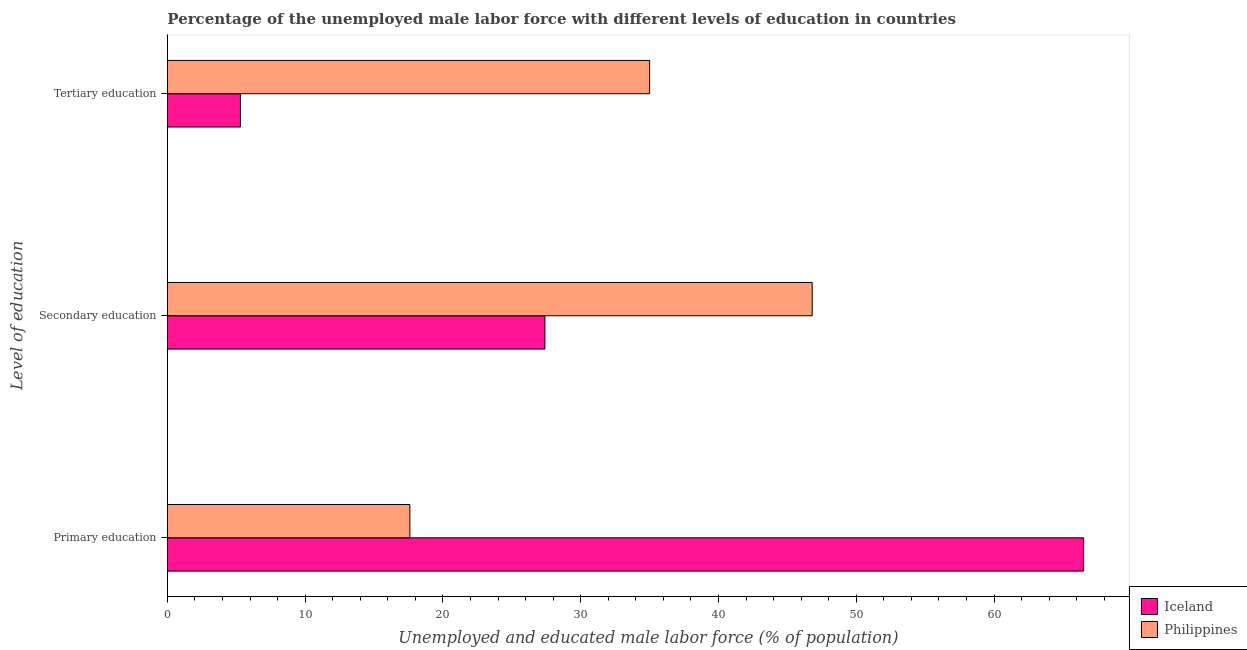How many different coloured bars are there?
Make the answer very short. 2. How many groups of bars are there?
Keep it short and to the point. 3. Are the number of bars per tick equal to the number of legend labels?
Provide a succinct answer. Yes. How many bars are there on the 3rd tick from the bottom?
Your answer should be compact. 2. What is the percentage of male labor force who received secondary education in Iceland?
Your response must be concise. 27.4. Across all countries, what is the maximum percentage of male labor force who received primary education?
Ensure brevity in your answer.  66.5. Across all countries, what is the minimum percentage of male labor force who received tertiary education?
Your answer should be compact. 5.3. What is the total percentage of male labor force who received primary education in the graph?
Your answer should be compact. 84.1. What is the difference between the percentage of male labor force who received tertiary education in Iceland and that in Philippines?
Your answer should be very brief. -29.7. What is the difference between the percentage of male labor force who received primary education in Philippines and the percentage of male labor force who received tertiary education in Iceland?
Your answer should be very brief. 12.3. What is the average percentage of male labor force who received secondary education per country?
Provide a short and direct response. 37.1. What is the difference between the percentage of male labor force who received tertiary education and percentage of male labor force who received secondary education in Philippines?
Your answer should be very brief. -11.8. What is the ratio of the percentage of male labor force who received secondary education in Iceland to that in Philippines?
Provide a short and direct response. 0.59. Is the percentage of male labor force who received secondary education in Philippines less than that in Iceland?
Offer a very short reply. No. Is the difference between the percentage of male labor force who received primary education in Iceland and Philippines greater than the difference between the percentage of male labor force who received tertiary education in Iceland and Philippines?
Offer a terse response. Yes. What is the difference between the highest and the second highest percentage of male labor force who received tertiary education?
Offer a terse response. 29.7. What is the difference between the highest and the lowest percentage of male labor force who received primary education?
Give a very brief answer. 48.9. What does the 2nd bar from the top in Primary education represents?
Your answer should be compact. Iceland. What does the 2nd bar from the bottom in Primary education represents?
Ensure brevity in your answer.  Philippines. Is it the case that in every country, the sum of the percentage of male labor force who received primary education and percentage of male labor force who received secondary education is greater than the percentage of male labor force who received tertiary education?
Your answer should be very brief. Yes. How many bars are there?
Ensure brevity in your answer.  6. Are all the bars in the graph horizontal?
Give a very brief answer. Yes. How many countries are there in the graph?
Provide a short and direct response. 2. What is the difference between two consecutive major ticks on the X-axis?
Provide a succinct answer. 10. Are the values on the major ticks of X-axis written in scientific E-notation?
Provide a succinct answer. No. Does the graph contain grids?
Your answer should be very brief. No. How many legend labels are there?
Ensure brevity in your answer.  2. What is the title of the graph?
Your response must be concise. Percentage of the unemployed male labor force with different levels of education in countries. What is the label or title of the X-axis?
Your response must be concise. Unemployed and educated male labor force (% of population). What is the label or title of the Y-axis?
Your answer should be compact. Level of education. What is the Unemployed and educated male labor force (% of population) of Iceland in Primary education?
Provide a short and direct response. 66.5. What is the Unemployed and educated male labor force (% of population) of Philippines in Primary education?
Keep it short and to the point. 17.6. What is the Unemployed and educated male labor force (% of population) of Iceland in Secondary education?
Offer a terse response. 27.4. What is the Unemployed and educated male labor force (% of population) in Philippines in Secondary education?
Make the answer very short. 46.8. What is the Unemployed and educated male labor force (% of population) of Iceland in Tertiary education?
Your response must be concise. 5.3. What is the Unemployed and educated male labor force (% of population) in Philippines in Tertiary education?
Offer a very short reply. 35. Across all Level of education, what is the maximum Unemployed and educated male labor force (% of population) in Iceland?
Provide a short and direct response. 66.5. Across all Level of education, what is the maximum Unemployed and educated male labor force (% of population) of Philippines?
Your answer should be very brief. 46.8. Across all Level of education, what is the minimum Unemployed and educated male labor force (% of population) of Iceland?
Provide a succinct answer. 5.3. Across all Level of education, what is the minimum Unemployed and educated male labor force (% of population) of Philippines?
Offer a terse response. 17.6. What is the total Unemployed and educated male labor force (% of population) in Iceland in the graph?
Keep it short and to the point. 99.2. What is the total Unemployed and educated male labor force (% of population) of Philippines in the graph?
Ensure brevity in your answer.  99.4. What is the difference between the Unemployed and educated male labor force (% of population) in Iceland in Primary education and that in Secondary education?
Provide a succinct answer. 39.1. What is the difference between the Unemployed and educated male labor force (% of population) of Philippines in Primary education and that in Secondary education?
Your answer should be very brief. -29.2. What is the difference between the Unemployed and educated male labor force (% of population) of Iceland in Primary education and that in Tertiary education?
Provide a short and direct response. 61.2. What is the difference between the Unemployed and educated male labor force (% of population) in Philippines in Primary education and that in Tertiary education?
Give a very brief answer. -17.4. What is the difference between the Unemployed and educated male labor force (% of population) in Iceland in Secondary education and that in Tertiary education?
Provide a succinct answer. 22.1. What is the difference between the Unemployed and educated male labor force (% of population) in Philippines in Secondary education and that in Tertiary education?
Make the answer very short. 11.8. What is the difference between the Unemployed and educated male labor force (% of population) of Iceland in Primary education and the Unemployed and educated male labor force (% of population) of Philippines in Tertiary education?
Make the answer very short. 31.5. What is the average Unemployed and educated male labor force (% of population) of Iceland per Level of education?
Keep it short and to the point. 33.07. What is the average Unemployed and educated male labor force (% of population) of Philippines per Level of education?
Your answer should be compact. 33.13. What is the difference between the Unemployed and educated male labor force (% of population) of Iceland and Unemployed and educated male labor force (% of population) of Philippines in Primary education?
Your answer should be very brief. 48.9. What is the difference between the Unemployed and educated male labor force (% of population) in Iceland and Unemployed and educated male labor force (% of population) in Philippines in Secondary education?
Provide a short and direct response. -19.4. What is the difference between the Unemployed and educated male labor force (% of population) in Iceland and Unemployed and educated male labor force (% of population) in Philippines in Tertiary education?
Provide a short and direct response. -29.7. What is the ratio of the Unemployed and educated male labor force (% of population) in Iceland in Primary education to that in Secondary education?
Your answer should be compact. 2.43. What is the ratio of the Unemployed and educated male labor force (% of population) in Philippines in Primary education to that in Secondary education?
Your answer should be compact. 0.38. What is the ratio of the Unemployed and educated male labor force (% of population) in Iceland in Primary education to that in Tertiary education?
Your answer should be compact. 12.55. What is the ratio of the Unemployed and educated male labor force (% of population) in Philippines in Primary education to that in Tertiary education?
Your response must be concise. 0.5. What is the ratio of the Unemployed and educated male labor force (% of population) of Iceland in Secondary education to that in Tertiary education?
Your answer should be compact. 5.17. What is the ratio of the Unemployed and educated male labor force (% of population) of Philippines in Secondary education to that in Tertiary education?
Provide a succinct answer. 1.34. What is the difference between the highest and the second highest Unemployed and educated male labor force (% of population) in Iceland?
Give a very brief answer. 39.1. What is the difference between the highest and the lowest Unemployed and educated male labor force (% of population) in Iceland?
Give a very brief answer. 61.2. What is the difference between the highest and the lowest Unemployed and educated male labor force (% of population) of Philippines?
Offer a very short reply. 29.2. 